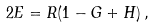Convert formula to latex. <formula><loc_0><loc_0><loc_500><loc_500>2 E = R ( 1 - G + H ) \, ,</formula> 